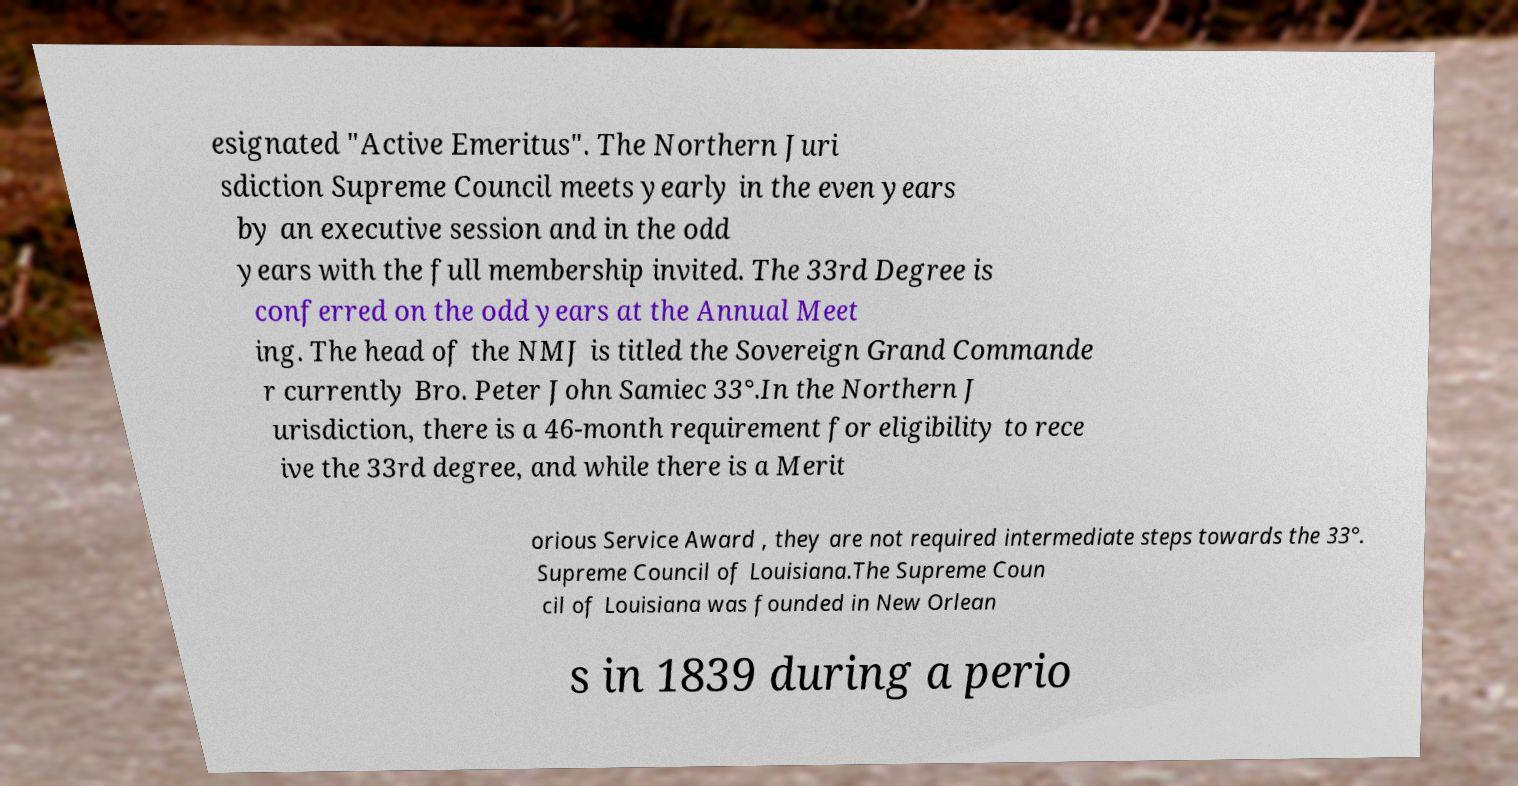For documentation purposes, I need the text within this image transcribed. Could you provide that? esignated "Active Emeritus". The Northern Juri sdiction Supreme Council meets yearly in the even years by an executive session and in the odd years with the full membership invited. The 33rd Degree is conferred on the odd years at the Annual Meet ing. The head of the NMJ is titled the Sovereign Grand Commande r currently Bro. Peter John Samiec 33°.In the Northern J urisdiction, there is a 46-month requirement for eligibility to rece ive the 33rd degree, and while there is a Merit orious Service Award , they are not required intermediate steps towards the 33°. Supreme Council of Louisiana.The Supreme Coun cil of Louisiana was founded in New Orlean s in 1839 during a perio 